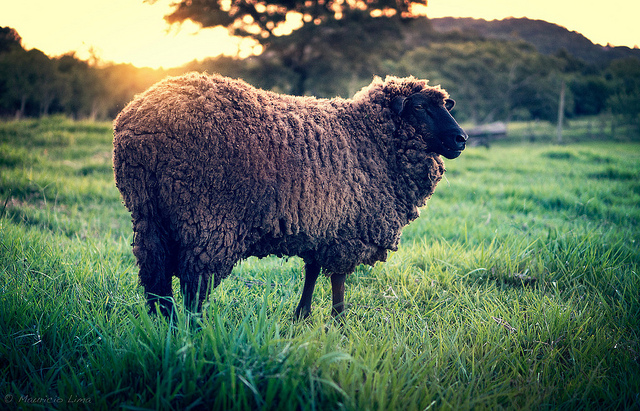Can you describe the environment surrounding the sheep? Of course. The sheep is in a lush, green field where the grass is quite tall, reaching up to its knees. The background features a picturesque setting with a line of trees and rolling hills. The sky is illuminated by the warm, golden hues of what seems to be either sunrise or sunset, giving the scene a tranquil and serene ambiance. 